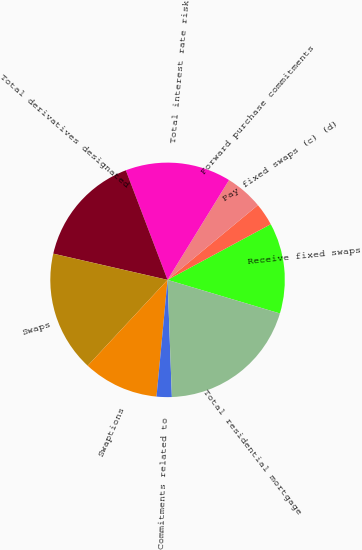Convert chart to OTSL. <chart><loc_0><loc_0><loc_500><loc_500><pie_chart><fcel>Receive fixed swaps<fcel>Pay fixed swaps (c) (d)<fcel>Forward purchase commitments<fcel>Total interest rate risk<fcel>Total derivatives designated<fcel>Swaps<fcel>Swaptions<fcel>Commitments related to<fcel>Total residential mortgage<nl><fcel>12.5%<fcel>3.13%<fcel>5.21%<fcel>14.58%<fcel>15.62%<fcel>16.67%<fcel>10.42%<fcel>2.09%<fcel>19.79%<nl></chart> 